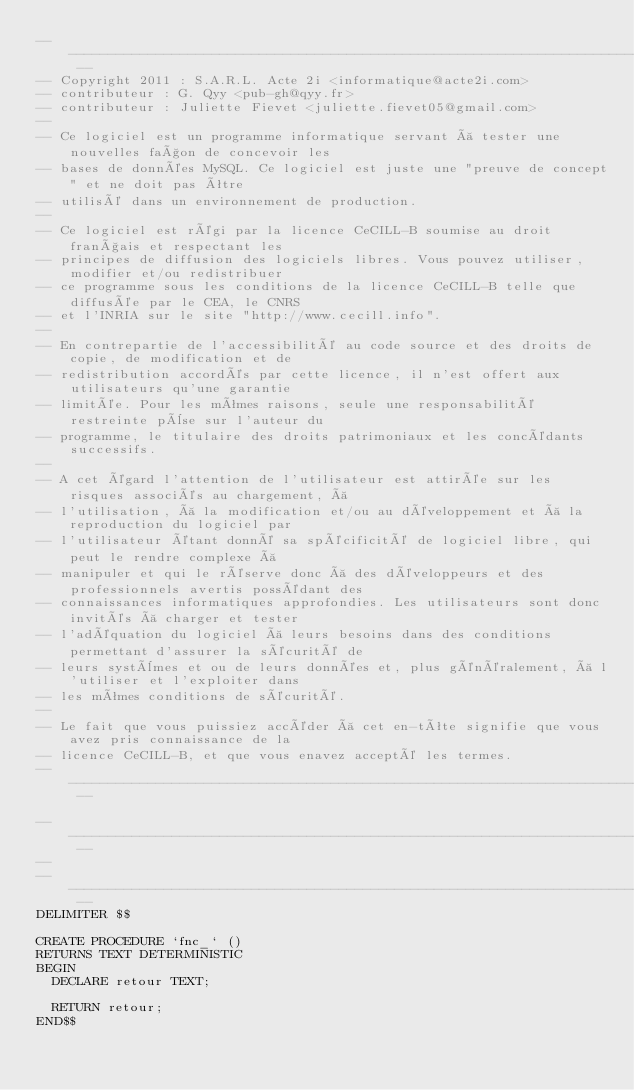<code> <loc_0><loc_0><loc_500><loc_500><_SQL_>-- ---------------------------------------------------------------------------------------------- --
-- Copyright 2011 : S.A.R.L. Acte 2i <informatique@acte2i.com>
-- contributeur : G. Qyy <pub-gh@qyy.fr>
-- contributeur : Juliette Fievet <juliette.fievet05@gmail.com>
-- 
-- Ce logiciel est un programme informatique servant à tester une nouvelles façon de concevoir les
-- bases de données MySQL. Ce logiciel est juste une "preuve de concept" et ne doit pas être
-- utilisé dans un environnement de production.
-- 
-- Ce logiciel est régi par la licence CeCILL-B soumise au droit français et respectant les
-- principes de diffusion des logiciels libres. Vous pouvez utiliser, modifier et/ou redistribuer
-- ce programme sous les conditions de la licence CeCILL-B telle que diffusée par le CEA, le CNRS
-- et l'INRIA sur le site "http://www.cecill.info".
-- 
-- En contrepartie de l'accessibilité au code source et des droits de copie, de modification et de
-- redistribution accordés par cette licence, il n'est offert aux utilisateurs qu'une garantie
-- limitée. Pour les mêmes raisons, seule une responsabilité restreinte pèse sur l'auteur du
-- programme, le titulaire des droits patrimoniaux et les concédants successifs.
-- 
-- A cet égard l'attention de l'utilisateur est attirée sur les risques associés au chargement, à
-- l'utilisation, à la modification et/ou au développement et à la reproduction du logiciel par
-- l'utilisateur étant donné sa spécificité de logiciel libre, qui peut le rendre complexe à
-- manipuler et qui le réserve donc à des développeurs et des professionnels avertis possédant des
-- connaissances informatiques approfondies. Les utilisateurs sont donc invités à charger et tester
-- l'adéquation du logiciel à leurs besoins dans des conditions permettant d'assurer la sécurité de
-- leurs systèmes et ou de leurs données et, plus généralement, à l'utiliser et l'exploiter dans
-- les mêmes conditions de sécurité. 
-- 
-- Le fait que vous puissiez accéder à cet en-tête signifie que vous avez pris connaissance de la
-- licence CeCILL-B, et que vous enavez accepté les termes.
-- ---------------------------------------------------------------------------------------------- --

-- ---------------------------------------------------------------------------------------------- --
-- 
-- ---------------------------------------------------------------------------------------------- --
DELIMITER $$

CREATE PROCEDURE `fnc_` ()
RETURNS TEXT DETERMINISTIC
BEGIN
  DECLARE retour TEXT;
  
  RETURN retour;
END$$</code> 